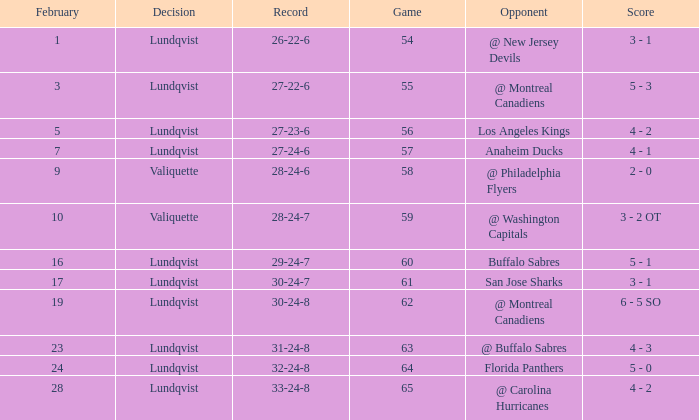What's the score for a game over 56 with a record of 29-24-7 with a lundqvist decision? 5 - 1. 